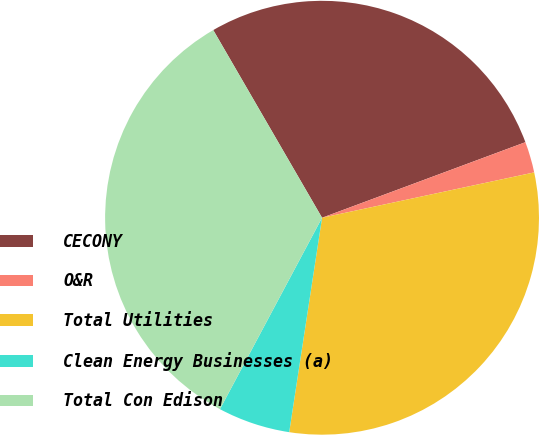Convert chart. <chart><loc_0><loc_0><loc_500><loc_500><pie_chart><fcel>CECONY<fcel>O&R<fcel>Total Utilities<fcel>Clean Energy Businesses (a)<fcel>Total Con Edison<nl><fcel>27.7%<fcel>2.31%<fcel>30.77%<fcel>5.38%<fcel>33.84%<nl></chart> 